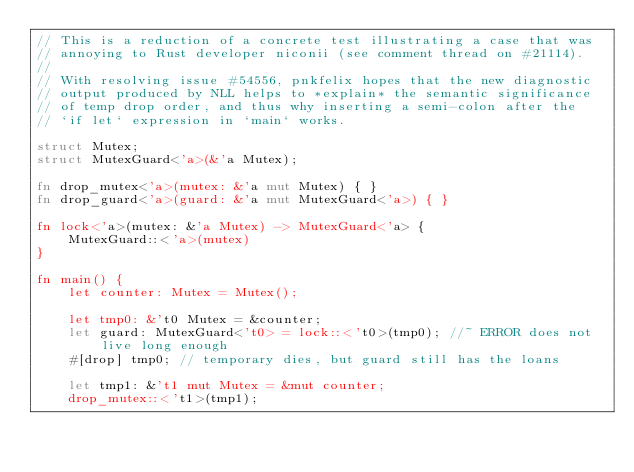Convert code to text. <code><loc_0><loc_0><loc_500><loc_500><_Rust_>// This is a reduction of a concrete test illustrating a case that was
// annoying to Rust developer niconii (see comment thread on #21114).
//
// With resolving issue #54556, pnkfelix hopes that the new diagnostic
// output produced by NLL helps to *explain* the semantic significance
// of temp drop order, and thus why inserting a semi-colon after the
// `if let` expression in `main` works.

struct Mutex;
struct MutexGuard<'a>(&'a Mutex);

fn drop_mutex<'a>(mutex: &'a mut Mutex) { }
fn drop_guard<'a>(guard: &'a mut MutexGuard<'a>) { }

fn lock<'a>(mutex: &'a Mutex) -> MutexGuard<'a> {
    MutexGuard::<'a>(mutex)
}

fn main() {
    let counter: Mutex = Mutex();

    let tmp0: &'t0 Mutex = &counter;
    let guard: MutexGuard<'t0> = lock::<'t0>(tmp0); //~ ERROR does not live long enough
    #[drop] tmp0; // temporary dies, but guard still has the loans

    let tmp1: &'t1 mut Mutex = &mut counter;
    drop_mutex::<'t1>(tmp1);</code> 